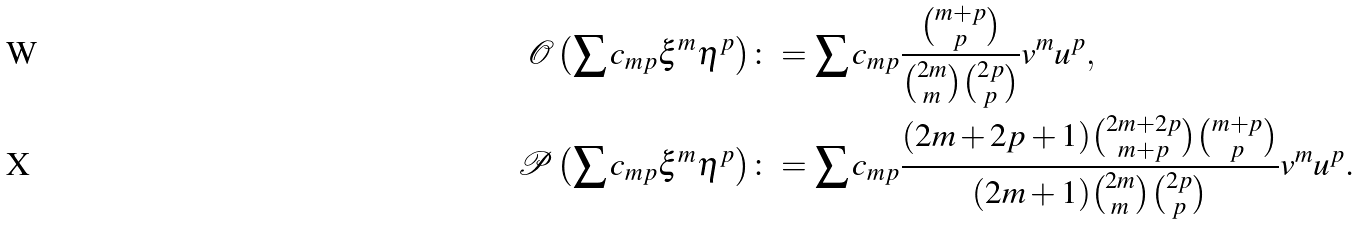<formula> <loc_0><loc_0><loc_500><loc_500>\mathcal { O } \left ( \sum c _ { m p } \xi ^ { m } \eta ^ { p } \right ) & \colon = \sum c _ { m p } \frac { \binom { m + p } { p } } { \binom { 2 m } { m } \binom { 2 p } { p } } v ^ { m } u ^ { p } , \\ \mathcal { P } \left ( \sum c _ { m p } \xi ^ { m } \eta ^ { p } \right ) & \colon = \sum c _ { m p } \frac { ( 2 m + 2 p + 1 ) \binom { 2 m + 2 p } { m + p } \binom { m + p } { p } } { ( 2 m + 1 ) \binom { 2 m } { m } \binom { 2 p } { p } } v ^ { m } u ^ { p } .</formula> 